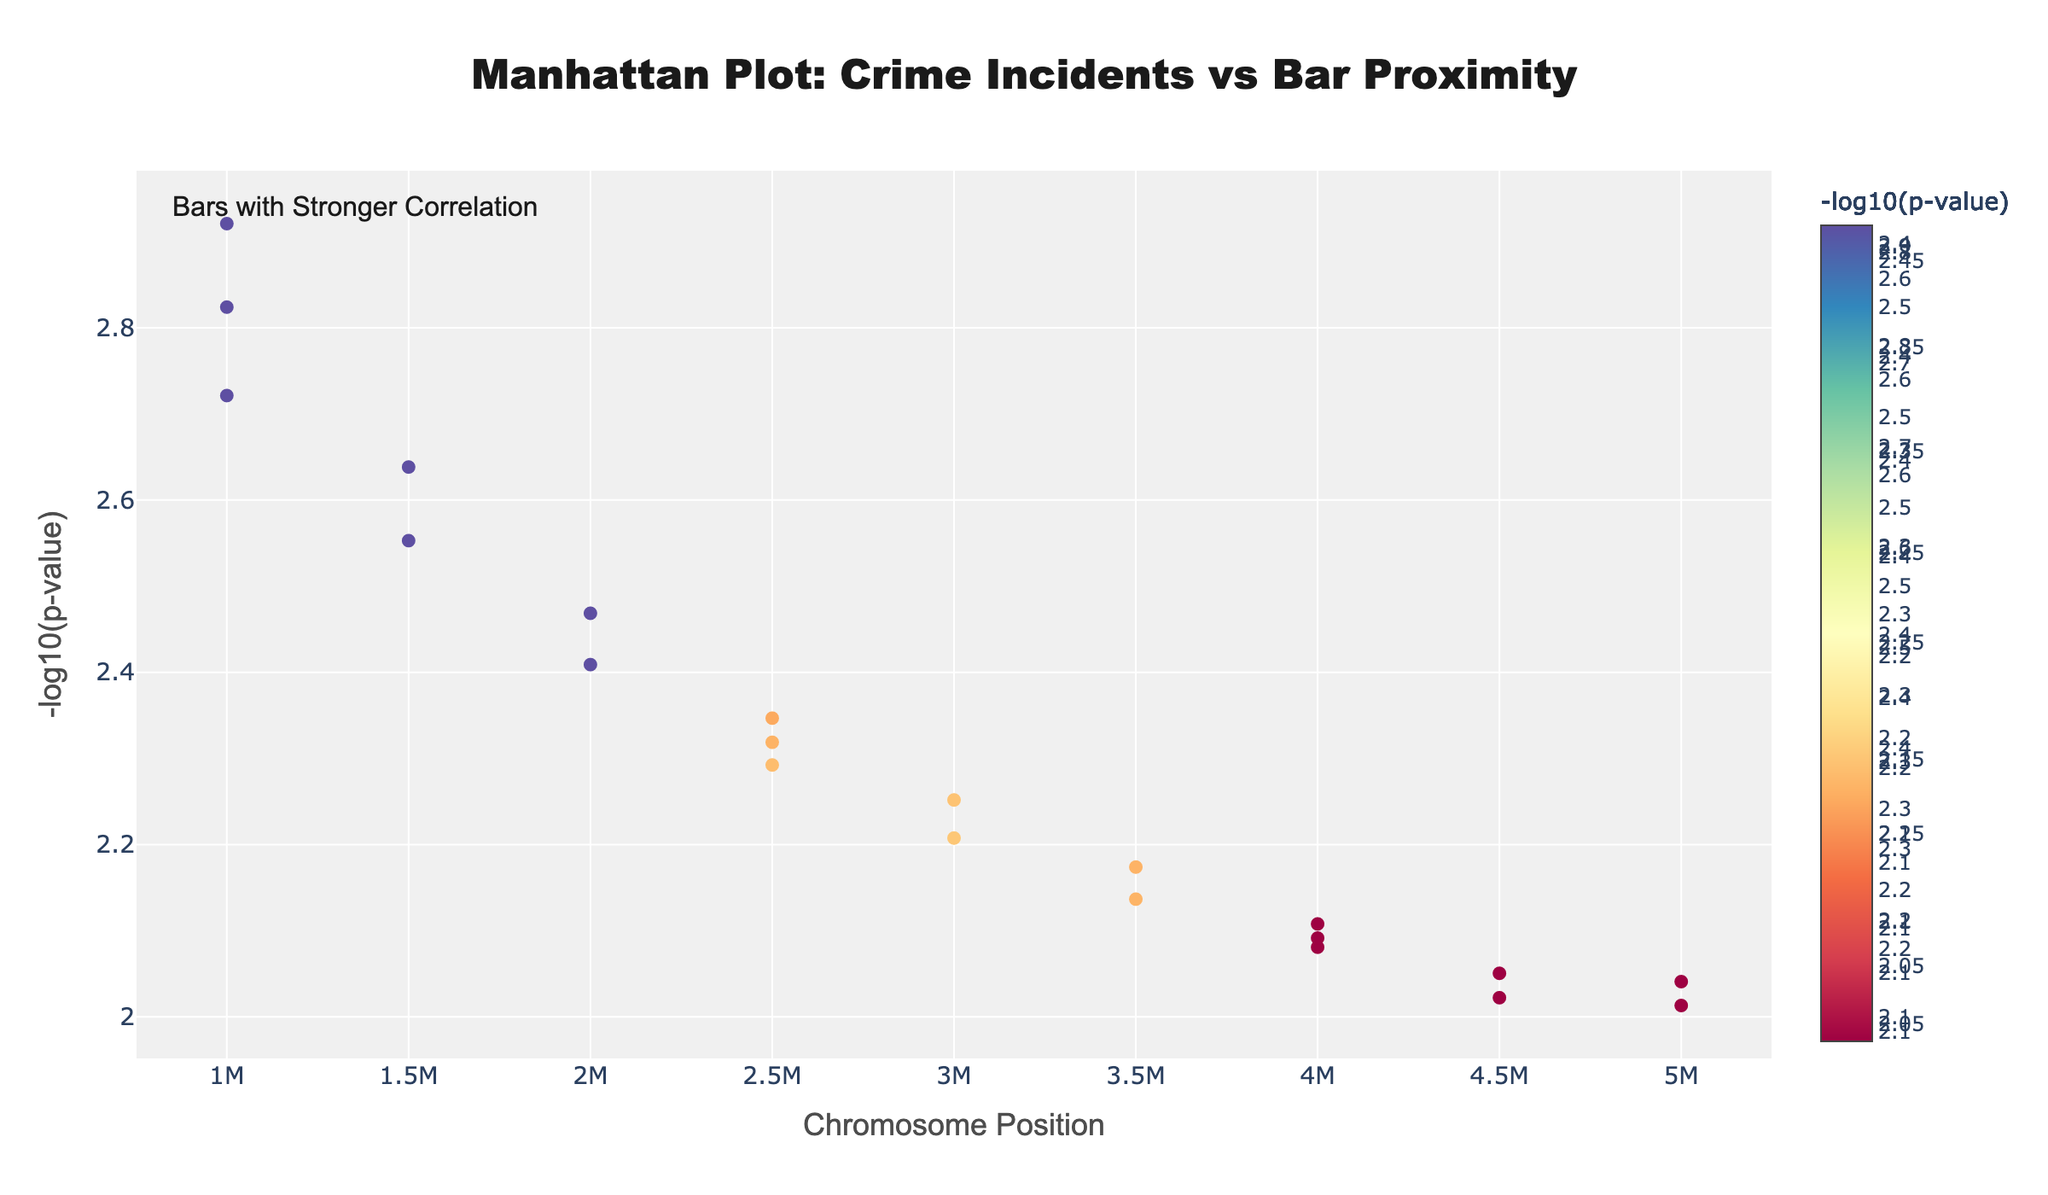Which chromosome contains the data point with the lowest p-value? To find the data point with the lowest p-value, look for the highest -log10(p-value) on the y-axis. The marker with the highest y-value is on Chromosome 1.
Answer: Chromosome 1 What is the range of p-values shown on the plot? Look at the range of -log10(p-value) values on the y-axis. These values range from approximately 1.1 to 3.0, which corresponds to p-values from 0.1 to 0.001.
Answer: 0.1 to 0.001 Which chromosome has bars with a higher concentration of significant correlations? Examine the density and height of data points. Chromosome 1 and Chromosome 2 have several data points with high -log10(p-value) values (indicating significant correlations).
Answer: Chromosome 1 and Chromosome 2 Which type of bar is correlated with the lowest p-value? Look for the marker with the highest -log10(p-value) and check the hover text for the bar type. The highest marker corresponds to a "Sports Bar."
Answer: Sports Bar What is the typical -log10(p-value) for data points associated with bars on Chromosome 3? Calculate the -log10(p-value) for each data point on Chromosome 3 (values are approximately 2.46, 2.17, and 2.04). The typical value is around the average of these, which is roughly 2.2.
Answer: Roughly 2.2 Is there a bar type that appears multiple times across different chromosomes? Look for recurring bar types in the hover texts across different chromosomes. Several bar types like 'Nightclub' appear only once, meaning no recurring bar types across different chromosomes.
Answer: No Which chromosome has the largest spread in position values? Compare the x-axis (position) values' range for each chromosome. Chromosome 6 spans from 2,000,000 to 5,000,000, which is the largest spread of 3,000,000 units.
Answer: Chromosome 6 How does the significance of correlations for 'Dive Bar' compare to 'Whiskey Bar'? Compare the -log10(p-value) values for 'Dive Bar' (around 2.25) and 'Whiskey Bar' (around 2.01). 'Dive Bar' has a higher -log10(p-value), indicating a more significant correlation.
Answer: Dive Bar has more significant correlation Are there any chromosomes that lack highly significant correlations? Check each chromosome for markers with high -log10(p-value) values. Chromosomes 3, 5, and 7 have fewer high-value points compared to others, indicating fewer significant correlations.
Answer: Chromosomes 3, 5, and 7 Do data points for 'Nightclub' and 'Jazz Club' have similar significance levels? Compare the -log10(p-value) values for 'Nightclub' (around 2.64) and 'Jazz Club' (around 2.29). They are similar but 'Nightclub' is slightly more significant.
Answer: Yes, they are similar 